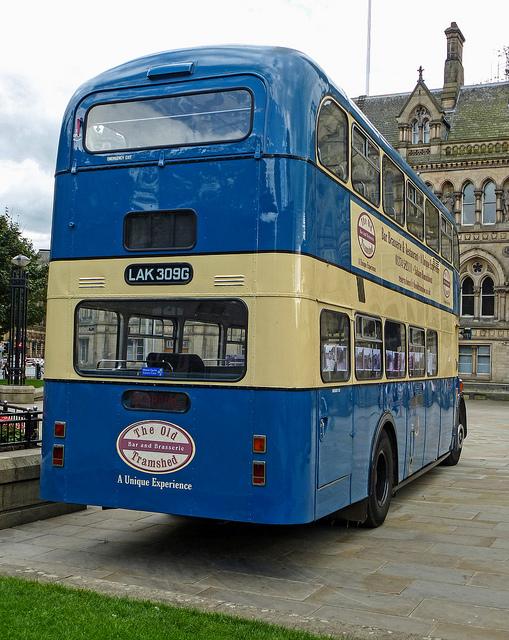What are the letters on the bus?
Keep it brief. Lak. What are the two colors of the bus?
Concise answer only. Blue and yellow. What colors are the bus?
Write a very short answer. Blue and tan. Is the building in the background ornate?
Concise answer only. Yes. 